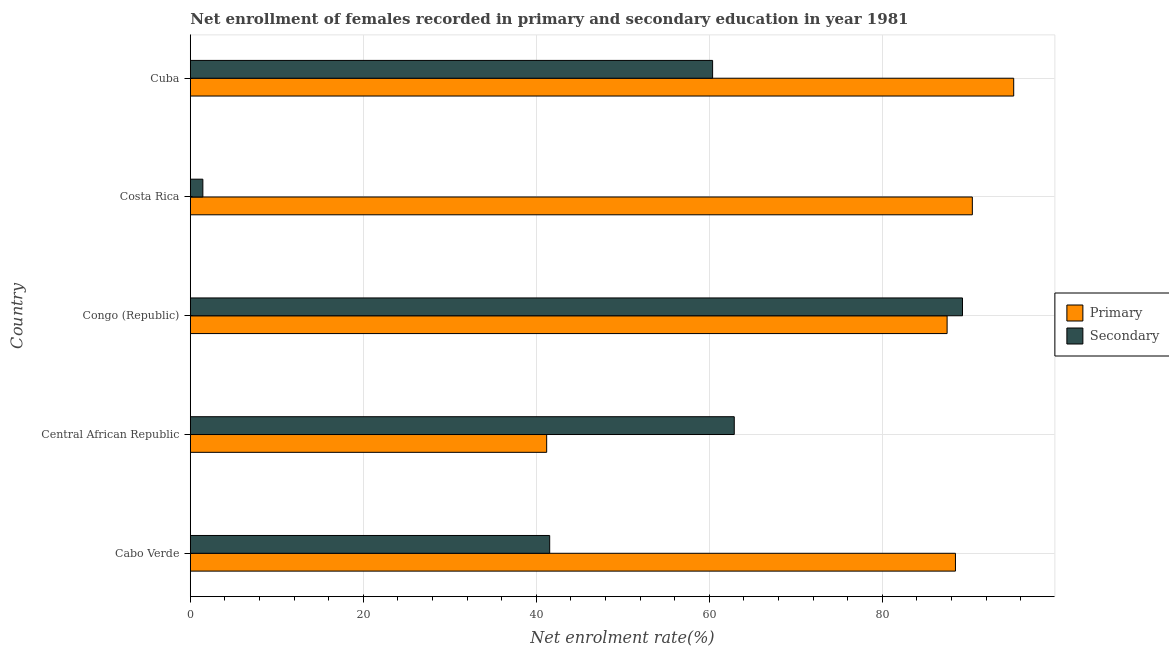How many different coloured bars are there?
Give a very brief answer. 2. How many groups of bars are there?
Keep it short and to the point. 5. Are the number of bars on each tick of the Y-axis equal?
Your answer should be compact. Yes. How many bars are there on the 3rd tick from the bottom?
Provide a short and direct response. 2. What is the label of the 4th group of bars from the top?
Provide a succinct answer. Central African Republic. In how many cases, is the number of bars for a given country not equal to the number of legend labels?
Provide a succinct answer. 0. What is the enrollment rate in primary education in Cuba?
Offer a very short reply. 95.2. Across all countries, what is the maximum enrollment rate in secondary education?
Give a very brief answer. 89.28. Across all countries, what is the minimum enrollment rate in primary education?
Your answer should be very brief. 41.2. In which country was the enrollment rate in secondary education maximum?
Ensure brevity in your answer.  Congo (Republic). What is the total enrollment rate in secondary education in the graph?
Your answer should be very brief. 255.56. What is the difference between the enrollment rate in primary education in Congo (Republic) and that in Costa Rica?
Provide a succinct answer. -2.92. What is the difference between the enrollment rate in primary education in Central African Republic and the enrollment rate in secondary education in Cuba?
Offer a terse response. -19.19. What is the average enrollment rate in primary education per country?
Make the answer very short. 80.56. What is the difference between the enrollment rate in primary education and enrollment rate in secondary education in Costa Rica?
Offer a very short reply. 88.97. In how many countries, is the enrollment rate in primary education greater than 52 %?
Keep it short and to the point. 4. What is the ratio of the enrollment rate in secondary education in Congo (Republic) to that in Costa Rica?
Provide a short and direct response. 61.48. Is the enrollment rate in secondary education in Congo (Republic) less than that in Costa Rica?
Offer a very short reply. No. What is the difference between the highest and the second highest enrollment rate in primary education?
Your answer should be compact. 4.78. What is the difference between the highest and the lowest enrollment rate in secondary education?
Your answer should be very brief. 87.83. In how many countries, is the enrollment rate in primary education greater than the average enrollment rate in primary education taken over all countries?
Offer a very short reply. 4. What does the 2nd bar from the top in Cabo Verde represents?
Provide a short and direct response. Primary. What does the 1st bar from the bottom in Cabo Verde represents?
Your answer should be very brief. Primary. How many bars are there?
Your response must be concise. 10. Are all the bars in the graph horizontal?
Make the answer very short. Yes. How many countries are there in the graph?
Offer a terse response. 5. Are the values on the major ticks of X-axis written in scientific E-notation?
Your answer should be very brief. No. Does the graph contain any zero values?
Offer a terse response. No. What is the title of the graph?
Make the answer very short. Net enrollment of females recorded in primary and secondary education in year 1981. What is the label or title of the X-axis?
Ensure brevity in your answer.  Net enrolment rate(%). What is the label or title of the Y-axis?
Provide a succinct answer. Country. What is the Net enrolment rate(%) in Primary in Cabo Verde?
Your answer should be very brief. 88.46. What is the Net enrolment rate(%) of Secondary in Cabo Verde?
Your answer should be very brief. 41.55. What is the Net enrolment rate(%) of Primary in Central African Republic?
Keep it short and to the point. 41.2. What is the Net enrolment rate(%) in Secondary in Central African Republic?
Keep it short and to the point. 62.89. What is the Net enrolment rate(%) in Primary in Congo (Republic)?
Offer a very short reply. 87.5. What is the Net enrolment rate(%) in Secondary in Congo (Republic)?
Your answer should be compact. 89.28. What is the Net enrolment rate(%) in Primary in Costa Rica?
Give a very brief answer. 90.42. What is the Net enrolment rate(%) in Secondary in Costa Rica?
Give a very brief answer. 1.45. What is the Net enrolment rate(%) in Primary in Cuba?
Give a very brief answer. 95.2. What is the Net enrolment rate(%) in Secondary in Cuba?
Provide a succinct answer. 60.39. Across all countries, what is the maximum Net enrolment rate(%) in Primary?
Provide a short and direct response. 95.2. Across all countries, what is the maximum Net enrolment rate(%) of Secondary?
Make the answer very short. 89.28. Across all countries, what is the minimum Net enrolment rate(%) of Primary?
Your answer should be very brief. 41.2. Across all countries, what is the minimum Net enrolment rate(%) in Secondary?
Keep it short and to the point. 1.45. What is the total Net enrolment rate(%) in Primary in the graph?
Your response must be concise. 402.78. What is the total Net enrolment rate(%) of Secondary in the graph?
Give a very brief answer. 255.56. What is the difference between the Net enrolment rate(%) of Primary in Cabo Verde and that in Central African Republic?
Provide a short and direct response. 47.26. What is the difference between the Net enrolment rate(%) of Secondary in Cabo Verde and that in Central African Republic?
Offer a very short reply. -21.34. What is the difference between the Net enrolment rate(%) in Primary in Cabo Verde and that in Congo (Republic)?
Provide a succinct answer. 0.97. What is the difference between the Net enrolment rate(%) in Secondary in Cabo Verde and that in Congo (Republic)?
Your answer should be compact. -47.73. What is the difference between the Net enrolment rate(%) in Primary in Cabo Verde and that in Costa Rica?
Offer a very short reply. -1.95. What is the difference between the Net enrolment rate(%) of Secondary in Cabo Verde and that in Costa Rica?
Keep it short and to the point. 40.1. What is the difference between the Net enrolment rate(%) in Primary in Cabo Verde and that in Cuba?
Provide a short and direct response. -6.73. What is the difference between the Net enrolment rate(%) of Secondary in Cabo Verde and that in Cuba?
Keep it short and to the point. -18.84. What is the difference between the Net enrolment rate(%) of Primary in Central African Republic and that in Congo (Republic)?
Ensure brevity in your answer.  -46.3. What is the difference between the Net enrolment rate(%) in Secondary in Central African Republic and that in Congo (Republic)?
Offer a very short reply. -26.39. What is the difference between the Net enrolment rate(%) in Primary in Central African Republic and that in Costa Rica?
Keep it short and to the point. -49.22. What is the difference between the Net enrolment rate(%) of Secondary in Central African Republic and that in Costa Rica?
Your answer should be compact. 61.44. What is the difference between the Net enrolment rate(%) in Primary in Central African Republic and that in Cuba?
Offer a terse response. -54. What is the difference between the Net enrolment rate(%) of Secondary in Central African Republic and that in Cuba?
Your answer should be compact. 2.5. What is the difference between the Net enrolment rate(%) in Primary in Congo (Republic) and that in Costa Rica?
Your answer should be compact. -2.92. What is the difference between the Net enrolment rate(%) in Secondary in Congo (Republic) and that in Costa Rica?
Make the answer very short. 87.83. What is the difference between the Net enrolment rate(%) in Primary in Congo (Republic) and that in Cuba?
Offer a very short reply. -7.7. What is the difference between the Net enrolment rate(%) of Secondary in Congo (Republic) and that in Cuba?
Your response must be concise. 28.89. What is the difference between the Net enrolment rate(%) in Primary in Costa Rica and that in Cuba?
Make the answer very short. -4.78. What is the difference between the Net enrolment rate(%) in Secondary in Costa Rica and that in Cuba?
Your answer should be very brief. -58.94. What is the difference between the Net enrolment rate(%) of Primary in Cabo Verde and the Net enrolment rate(%) of Secondary in Central African Republic?
Your answer should be compact. 25.57. What is the difference between the Net enrolment rate(%) in Primary in Cabo Verde and the Net enrolment rate(%) in Secondary in Congo (Republic)?
Provide a short and direct response. -0.81. What is the difference between the Net enrolment rate(%) of Primary in Cabo Verde and the Net enrolment rate(%) of Secondary in Costa Rica?
Your response must be concise. 87.01. What is the difference between the Net enrolment rate(%) in Primary in Cabo Verde and the Net enrolment rate(%) in Secondary in Cuba?
Provide a succinct answer. 28.08. What is the difference between the Net enrolment rate(%) of Primary in Central African Republic and the Net enrolment rate(%) of Secondary in Congo (Republic)?
Provide a short and direct response. -48.08. What is the difference between the Net enrolment rate(%) in Primary in Central African Republic and the Net enrolment rate(%) in Secondary in Costa Rica?
Your answer should be compact. 39.75. What is the difference between the Net enrolment rate(%) in Primary in Central African Republic and the Net enrolment rate(%) in Secondary in Cuba?
Your response must be concise. -19.19. What is the difference between the Net enrolment rate(%) in Primary in Congo (Republic) and the Net enrolment rate(%) in Secondary in Costa Rica?
Offer a very short reply. 86.05. What is the difference between the Net enrolment rate(%) in Primary in Congo (Republic) and the Net enrolment rate(%) in Secondary in Cuba?
Keep it short and to the point. 27.11. What is the difference between the Net enrolment rate(%) in Primary in Costa Rica and the Net enrolment rate(%) in Secondary in Cuba?
Keep it short and to the point. 30.03. What is the average Net enrolment rate(%) in Primary per country?
Your answer should be compact. 80.56. What is the average Net enrolment rate(%) in Secondary per country?
Your answer should be compact. 51.11. What is the difference between the Net enrolment rate(%) in Primary and Net enrolment rate(%) in Secondary in Cabo Verde?
Your response must be concise. 46.91. What is the difference between the Net enrolment rate(%) in Primary and Net enrolment rate(%) in Secondary in Central African Republic?
Ensure brevity in your answer.  -21.69. What is the difference between the Net enrolment rate(%) of Primary and Net enrolment rate(%) of Secondary in Congo (Republic)?
Offer a terse response. -1.78. What is the difference between the Net enrolment rate(%) of Primary and Net enrolment rate(%) of Secondary in Costa Rica?
Make the answer very short. 88.97. What is the difference between the Net enrolment rate(%) in Primary and Net enrolment rate(%) in Secondary in Cuba?
Give a very brief answer. 34.81. What is the ratio of the Net enrolment rate(%) of Primary in Cabo Verde to that in Central African Republic?
Give a very brief answer. 2.15. What is the ratio of the Net enrolment rate(%) in Secondary in Cabo Verde to that in Central African Republic?
Provide a succinct answer. 0.66. What is the ratio of the Net enrolment rate(%) in Primary in Cabo Verde to that in Congo (Republic)?
Make the answer very short. 1.01. What is the ratio of the Net enrolment rate(%) of Secondary in Cabo Verde to that in Congo (Republic)?
Give a very brief answer. 0.47. What is the ratio of the Net enrolment rate(%) in Primary in Cabo Verde to that in Costa Rica?
Your answer should be compact. 0.98. What is the ratio of the Net enrolment rate(%) in Secondary in Cabo Verde to that in Costa Rica?
Provide a short and direct response. 28.61. What is the ratio of the Net enrolment rate(%) of Primary in Cabo Verde to that in Cuba?
Make the answer very short. 0.93. What is the ratio of the Net enrolment rate(%) of Secondary in Cabo Verde to that in Cuba?
Your answer should be compact. 0.69. What is the ratio of the Net enrolment rate(%) of Primary in Central African Republic to that in Congo (Republic)?
Your answer should be very brief. 0.47. What is the ratio of the Net enrolment rate(%) of Secondary in Central African Republic to that in Congo (Republic)?
Make the answer very short. 0.7. What is the ratio of the Net enrolment rate(%) in Primary in Central African Republic to that in Costa Rica?
Provide a succinct answer. 0.46. What is the ratio of the Net enrolment rate(%) in Secondary in Central African Republic to that in Costa Rica?
Your answer should be compact. 43.31. What is the ratio of the Net enrolment rate(%) of Primary in Central African Republic to that in Cuba?
Ensure brevity in your answer.  0.43. What is the ratio of the Net enrolment rate(%) in Secondary in Central African Republic to that in Cuba?
Provide a succinct answer. 1.04. What is the ratio of the Net enrolment rate(%) in Primary in Congo (Republic) to that in Costa Rica?
Keep it short and to the point. 0.97. What is the ratio of the Net enrolment rate(%) in Secondary in Congo (Republic) to that in Costa Rica?
Provide a succinct answer. 61.48. What is the ratio of the Net enrolment rate(%) of Primary in Congo (Republic) to that in Cuba?
Provide a short and direct response. 0.92. What is the ratio of the Net enrolment rate(%) in Secondary in Congo (Republic) to that in Cuba?
Provide a short and direct response. 1.48. What is the ratio of the Net enrolment rate(%) in Primary in Costa Rica to that in Cuba?
Your response must be concise. 0.95. What is the ratio of the Net enrolment rate(%) of Secondary in Costa Rica to that in Cuba?
Provide a succinct answer. 0.02. What is the difference between the highest and the second highest Net enrolment rate(%) of Primary?
Your answer should be compact. 4.78. What is the difference between the highest and the second highest Net enrolment rate(%) of Secondary?
Your response must be concise. 26.39. What is the difference between the highest and the lowest Net enrolment rate(%) in Primary?
Provide a short and direct response. 54. What is the difference between the highest and the lowest Net enrolment rate(%) in Secondary?
Provide a succinct answer. 87.83. 